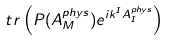<formula> <loc_0><loc_0><loc_500><loc_500>\ t r \left ( P ( A _ { M } ^ { p h y s } ) e ^ { i k ^ { I } A _ { I } ^ { p h y s } } \right )</formula> 